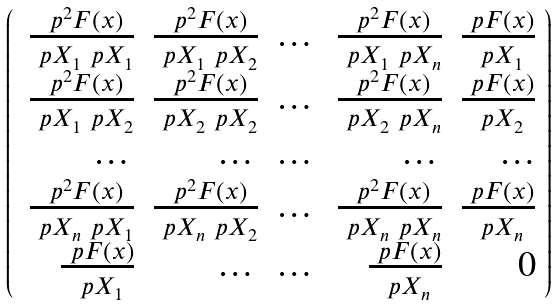Convert formula to latex. <formula><loc_0><loc_0><loc_500><loc_500>\left ( \begin{array} { r r r r r } \, \frac { \ p ^ { 2 } F ( x ) } { \ p X _ { 1 } \ p X _ { 1 } } & \frac { \ p ^ { 2 } F ( x ) } { \ p X _ { 1 } \ p X _ { 2 } } & \dots & \frac { \ p ^ { 2 } F ( x ) } { \ p X _ { 1 } \ p X _ { n } } & \frac { \ p F ( x ) } { \ p X _ { 1 } } \\ \, \frac { \ p ^ { 2 } F ( x ) } { \ p X _ { 1 } \ p X _ { 2 } } & \frac { \ p ^ { 2 } F ( x ) } { \ p X _ { 2 } \ p X _ { 2 } } & \dots & \frac { \ p ^ { 2 } F ( x ) } { \ p X _ { 2 } \ p X _ { n } } & \frac { \ p F ( x ) } { \ p X _ { 2 } } \\ \dots & \dots & \dots & \dots & \dots \\ \, \frac { \ p ^ { 2 } F ( x ) } { \ p X _ { n } \ p X _ { 1 } } & \frac { \ p ^ { 2 } F ( x ) } { \ p X _ { n } \ p X _ { 2 } } & \dots & \frac { \ p ^ { 2 } F ( x ) } { \ p X _ { n } \ p X _ { n } } & \frac { \ p F ( x ) } { \ p X _ { n } } \\ \frac { \ p F ( x ) } { \ p X _ { 1 } } & \dots & \dots & \frac { \ p F ( x ) } { \ p X _ { n } } & 0 \end{array} \right )</formula> 